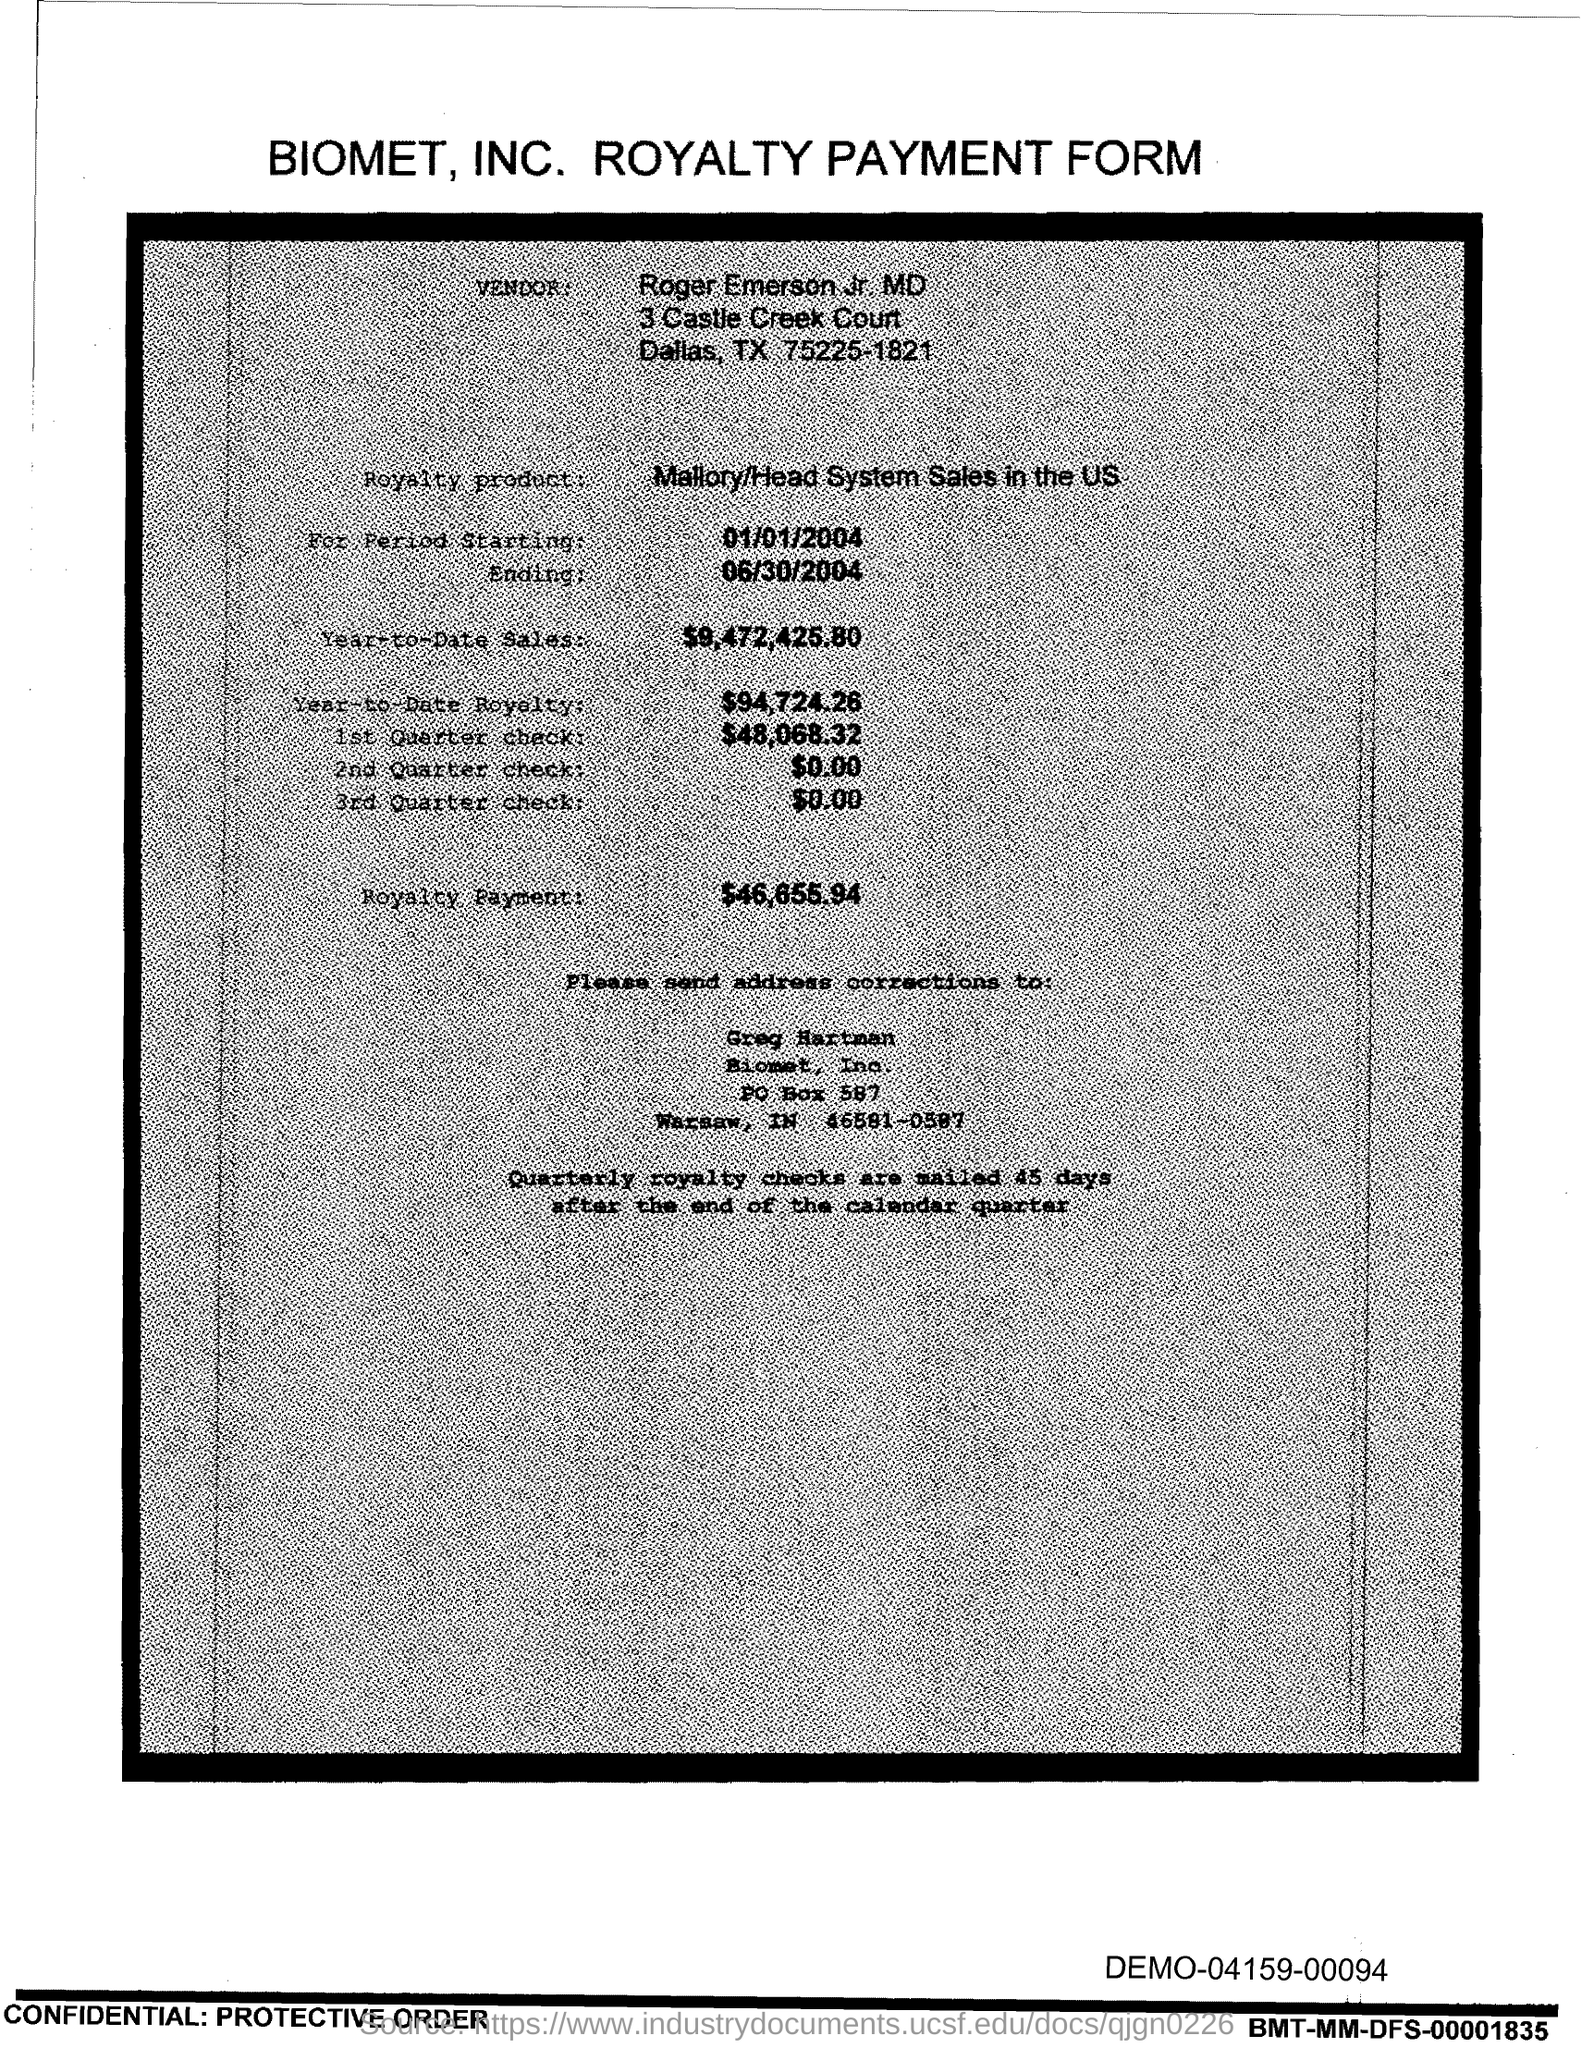Specify some key components in this picture. The Year-to-Date Sales as of today are $9,472,425.80. 